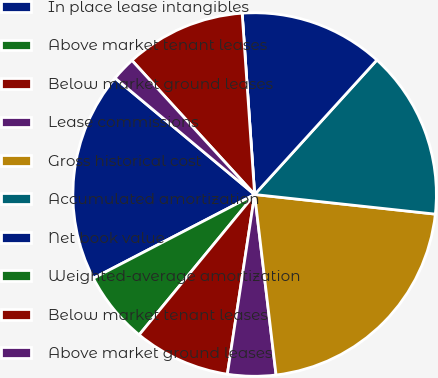Convert chart. <chart><loc_0><loc_0><loc_500><loc_500><pie_chart><fcel>In place lease intangibles<fcel>Above market tenant leases<fcel>Below market ground leases<fcel>Lease commissions<fcel>Gross historical cost<fcel>Accumulated amortization<fcel>Net book value<fcel>Weighted-average amortization<fcel>Below market tenant leases<fcel>Above market ground leases<nl><fcel>18.69%<fcel>6.42%<fcel>8.56%<fcel>4.28%<fcel>21.4%<fcel>14.98%<fcel>12.84%<fcel>0.0%<fcel>10.7%<fcel>2.14%<nl></chart> 